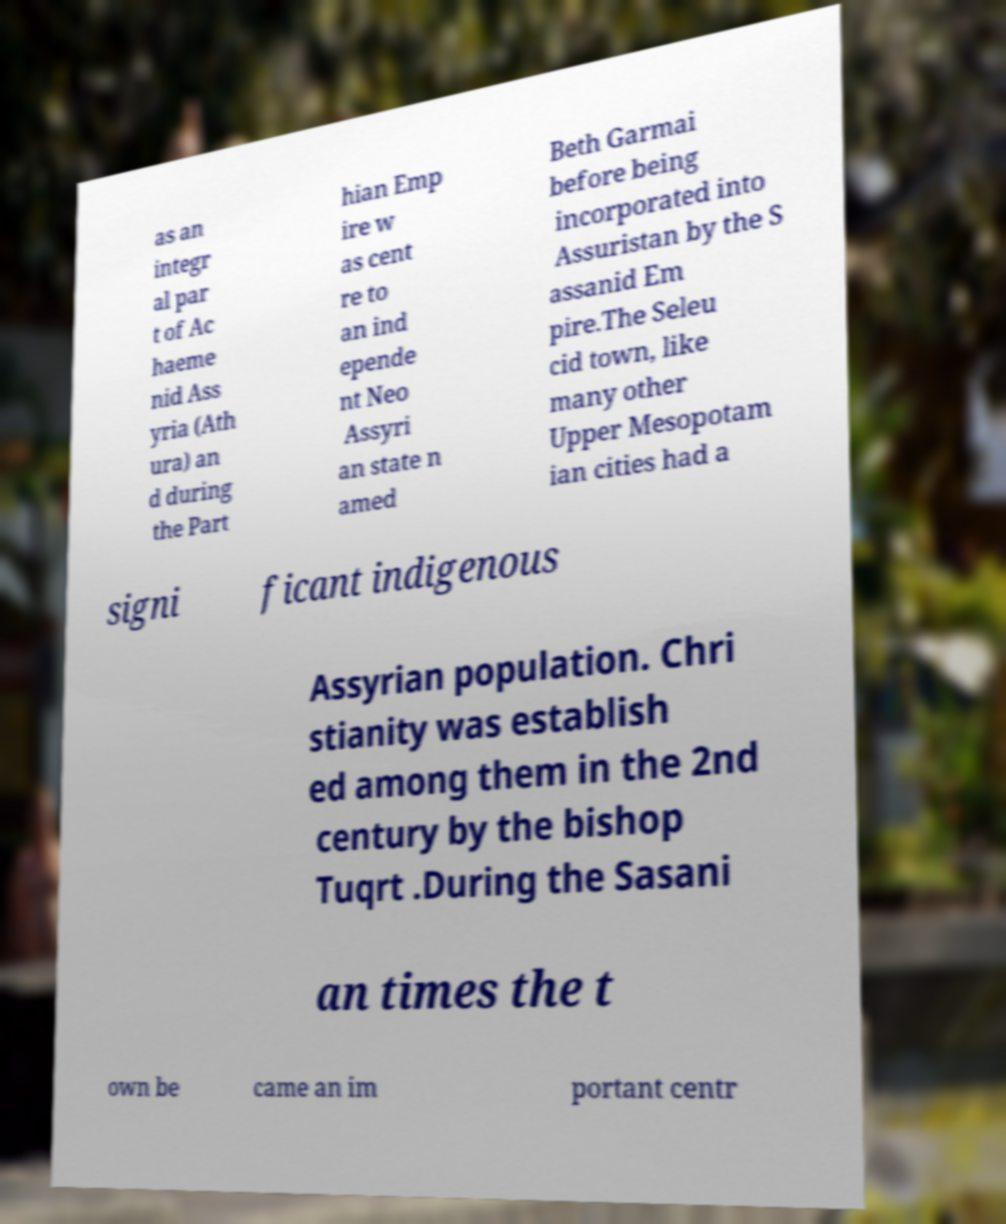Can you read and provide the text displayed in the image?This photo seems to have some interesting text. Can you extract and type it out for me? as an integr al par t of Ac haeme nid Ass yria (Ath ura) an d during the Part hian Emp ire w as cent re to an ind epende nt Neo Assyri an state n amed Beth Garmai before being incorporated into Assuristan by the S assanid Em pire.The Seleu cid town, like many other Upper Mesopotam ian cities had a signi ficant indigenous Assyrian population. Chri stianity was establish ed among them in the 2nd century by the bishop Tuqrt .During the Sasani an times the t own be came an im portant centr 